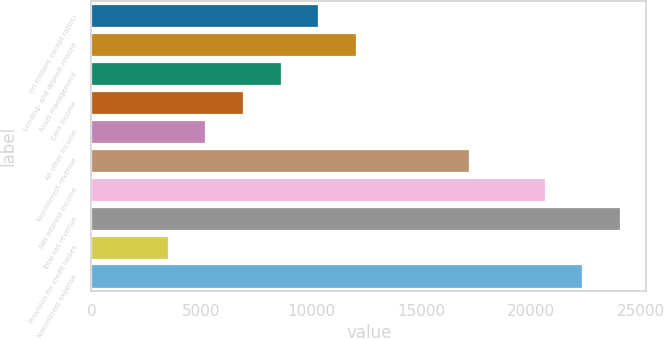Convert chart to OTSL. <chart><loc_0><loc_0><loc_500><loc_500><bar_chart><fcel>(in millions except ratios)<fcel>Lending- and deposit-related<fcel>Asset management<fcel>Card income<fcel>All other income<fcel>Noninterest revenue<fcel>Net interest income<fcel>Total net revenue<fcel>Provision for credit losses<fcel>Noninterest expense<nl><fcel>10326<fcel>12041<fcel>8611<fcel>6896<fcel>5181<fcel>17186<fcel>20616<fcel>24046<fcel>3466<fcel>22331<nl></chart> 